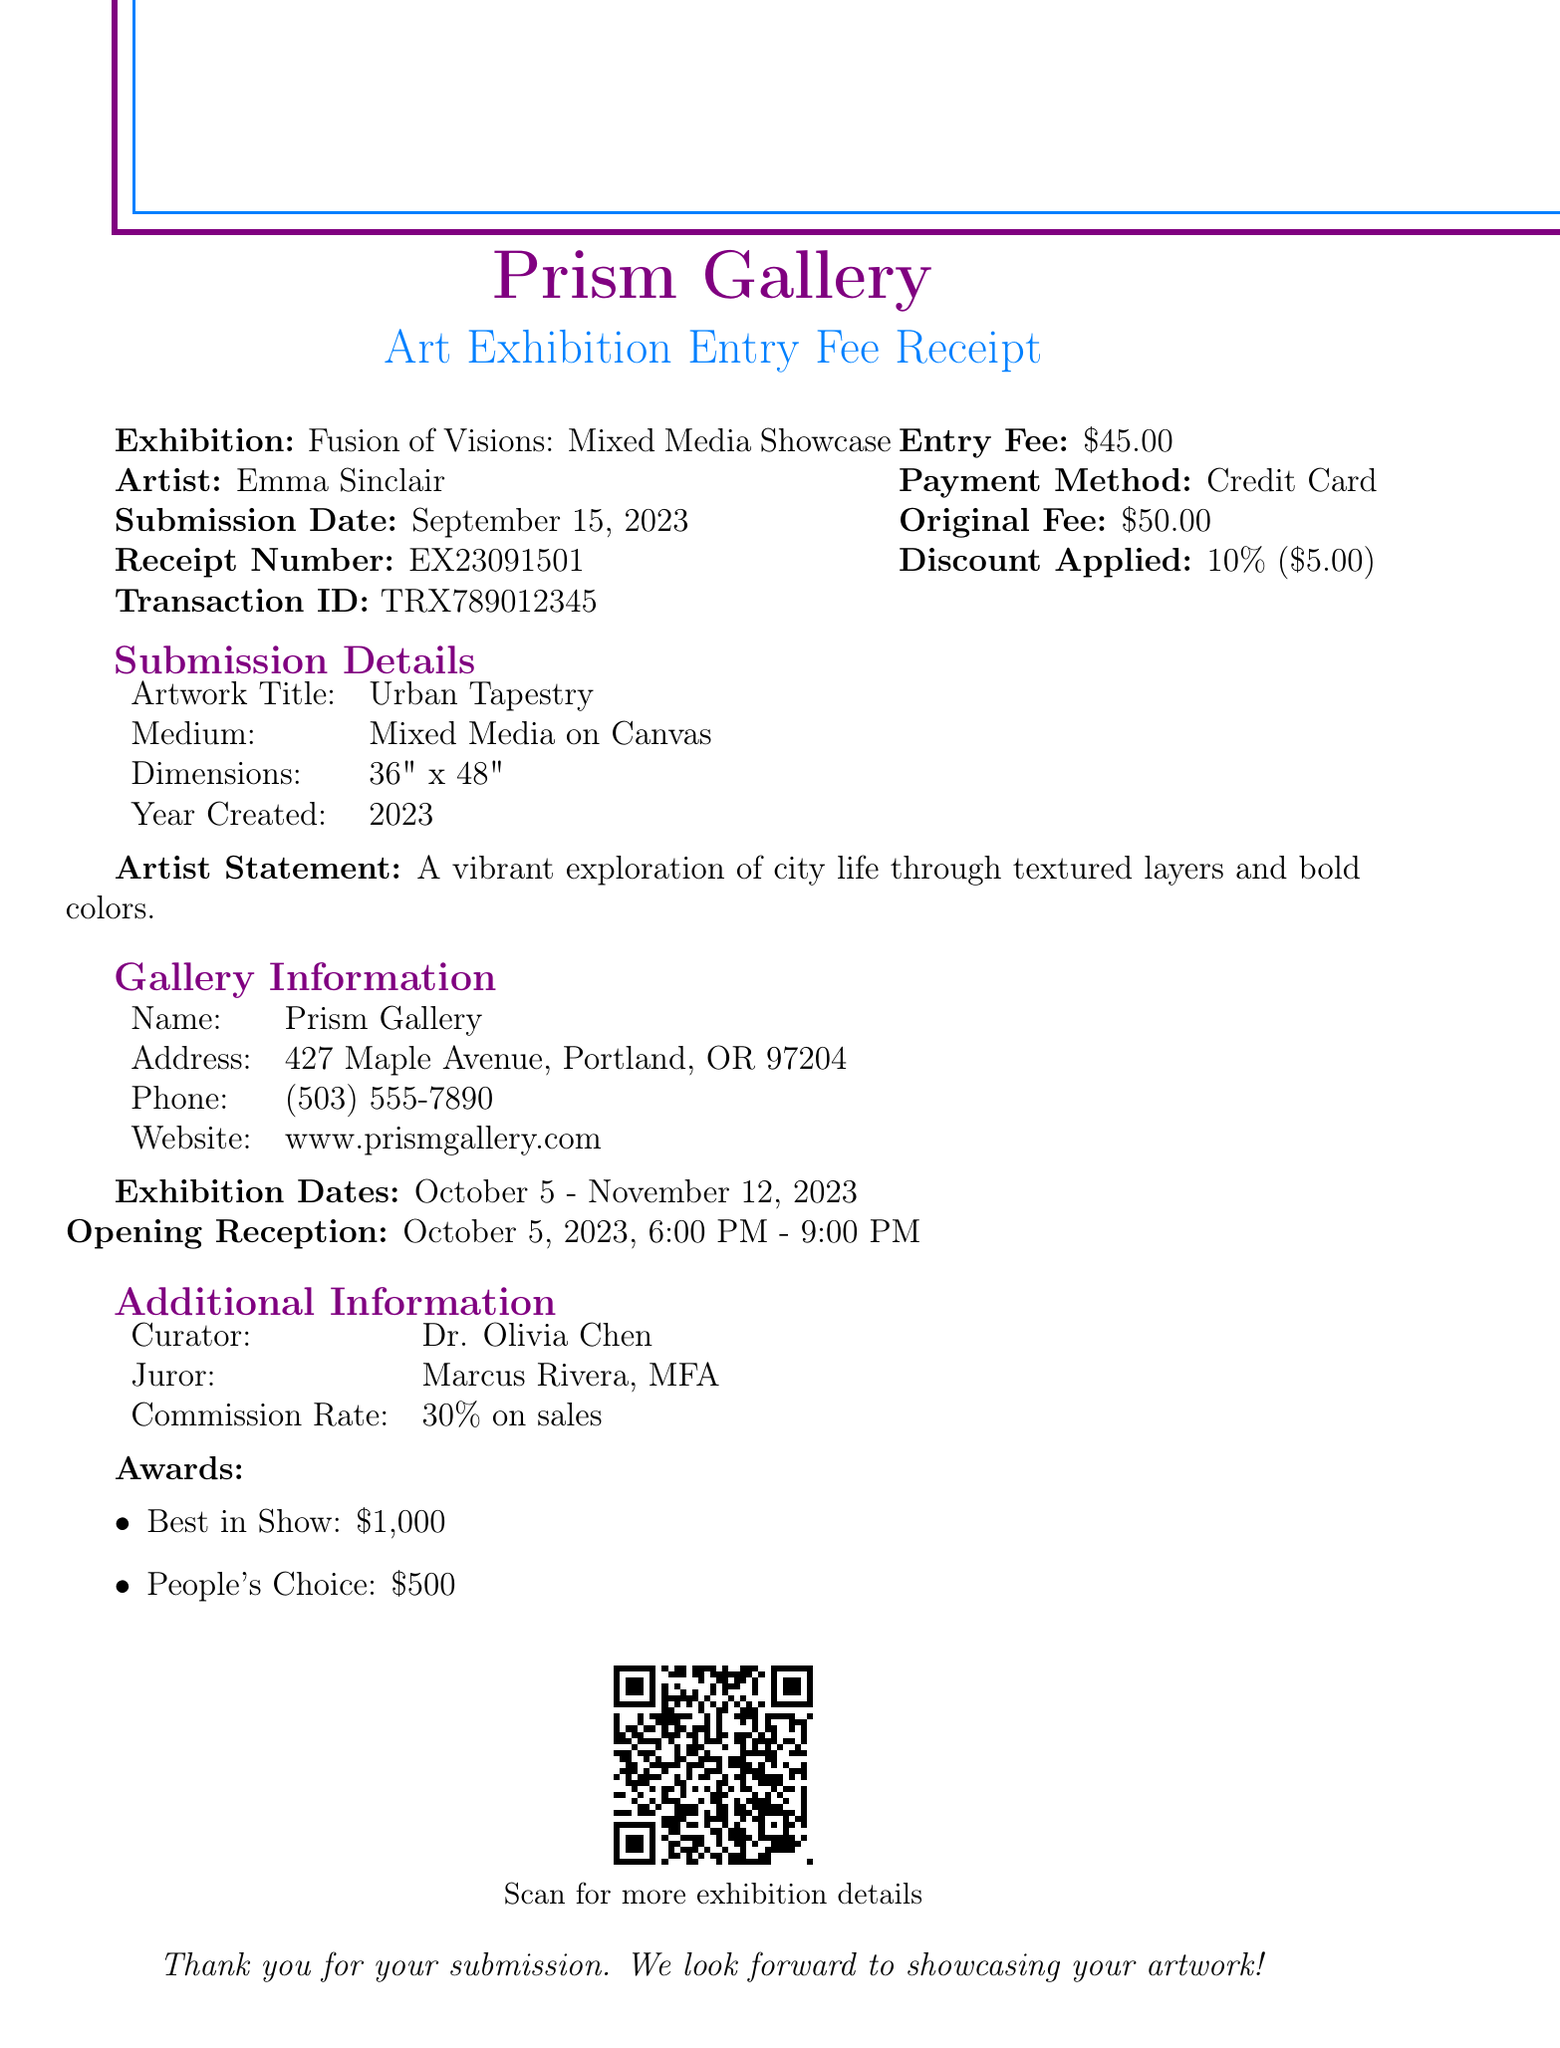What is the exhibition name? The exhibition name is listed in the document as the title of the event.
Answer: Fusion of Visions: Mixed Media Showcase Who is the artist? The artist's name is provided in the document under the artist information section.
Answer: Emma Sinclair What is the entry fee? The entry fee is stated clearly in the monetary section of the receipt.
Answer: $45.00 What was the submission date? The submission date is given in a specific date format within the document.
Answer: September 15, 2023 What medium was used for the artwork? The medium of the artwork is detailed in the submission details section of the document.
Answer: Mixed Media on Canvas How much was the discount applied? The discount amount is specified in the pricing section and shows the reduction on the original fee.
Answer: $5.00 What is the commission rate on sales? The commission rate is found in the additional information section of the document.
Answer: 30% on sales How many awards are mentioned in the document? The awards listed in the additional information section imply multiple recognition types.
Answer: 2 When is the opening reception? The opening reception date and time are clearly stated in the gallery information section.
Answer: October 5, 2023, 6:00 PM - 9:00 PM What is the receipt number? The receipt number is a unique identifier positioned in the monetary section of the document.
Answer: EX23091501 